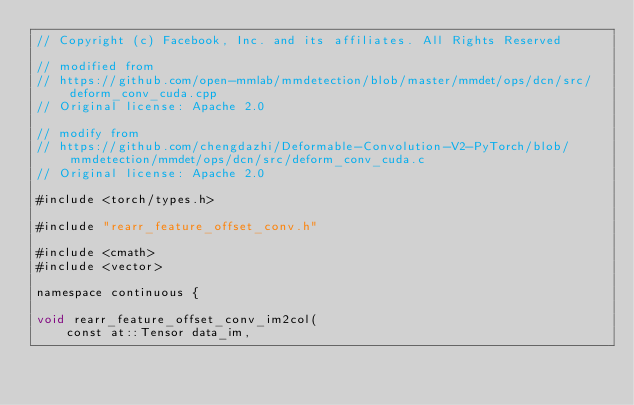<code> <loc_0><loc_0><loc_500><loc_500><_Cuda_>// Copyright (c) Facebook, Inc. and its affiliates. All Rights Reserved

// modified from
// https://github.com/open-mmlab/mmdetection/blob/master/mmdet/ops/dcn/src/deform_conv_cuda.cpp
// Original license: Apache 2.0

// modify from
// https://github.com/chengdazhi/Deformable-Convolution-V2-PyTorch/blob/mmdetection/mmdet/ops/dcn/src/deform_conv_cuda.c
// Original license: Apache 2.0

#include <torch/types.h>

#include "rearr_feature_offset_conv.h"

#include <cmath>
#include <vector>

namespace continuous {

void rearr_feature_offset_conv_im2col(
    const at::Tensor data_im,</code> 